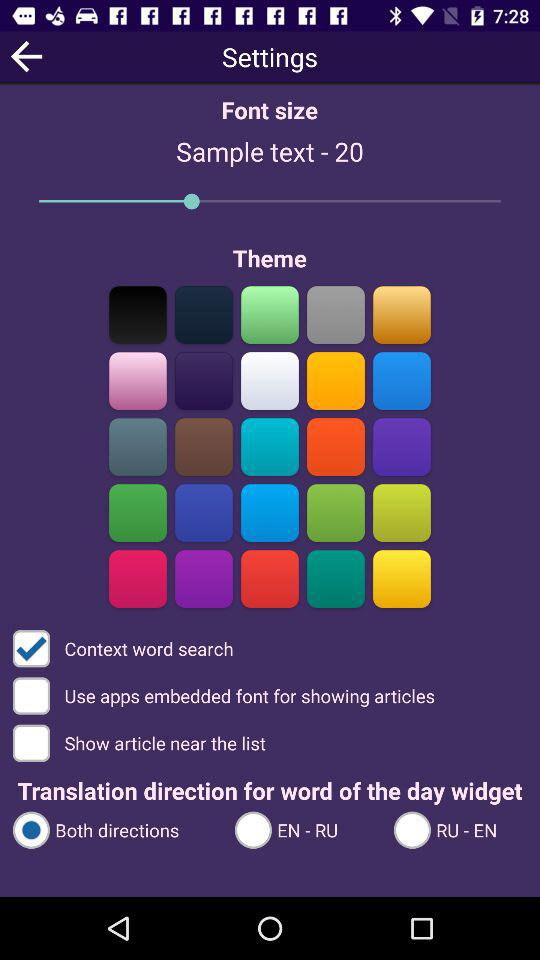How many options are there for the translation direction?
Answer the question using a single word or phrase. 3 